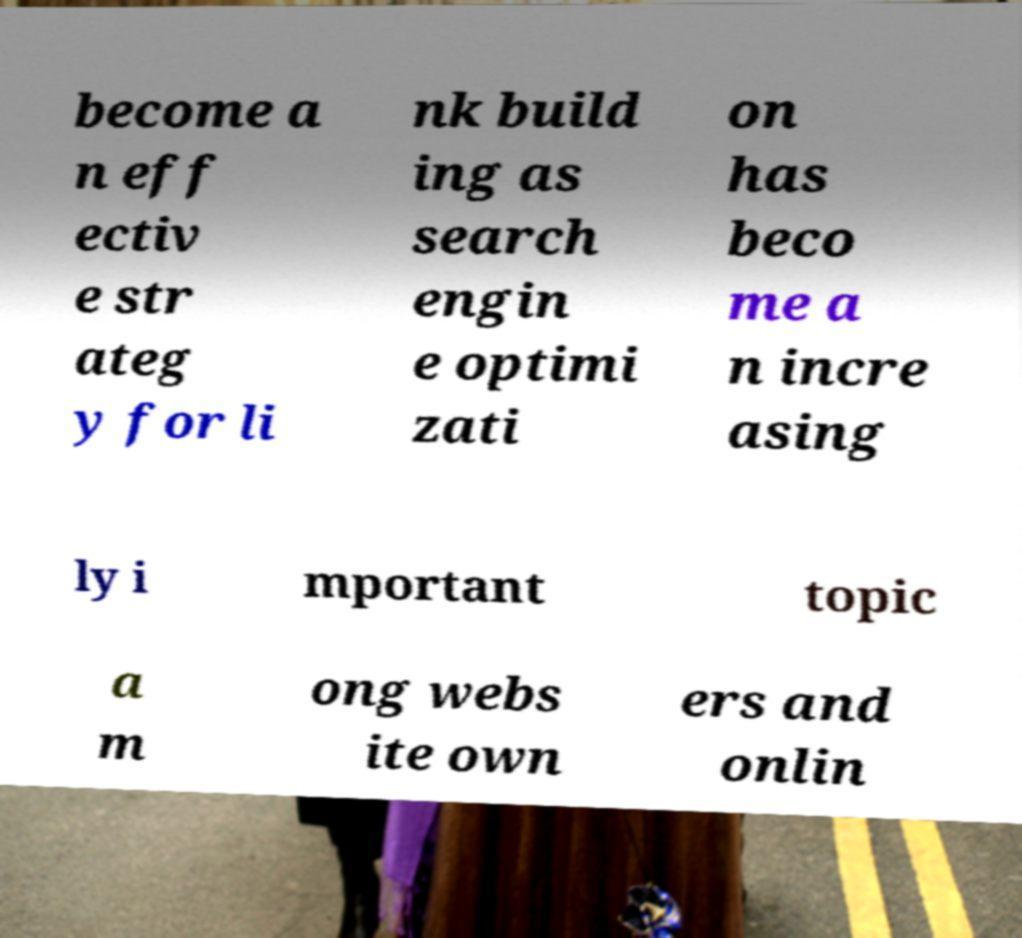I need the written content from this picture converted into text. Can you do that? become a n eff ectiv e str ateg y for li nk build ing as search engin e optimi zati on has beco me a n incre asing ly i mportant topic a m ong webs ite own ers and onlin 